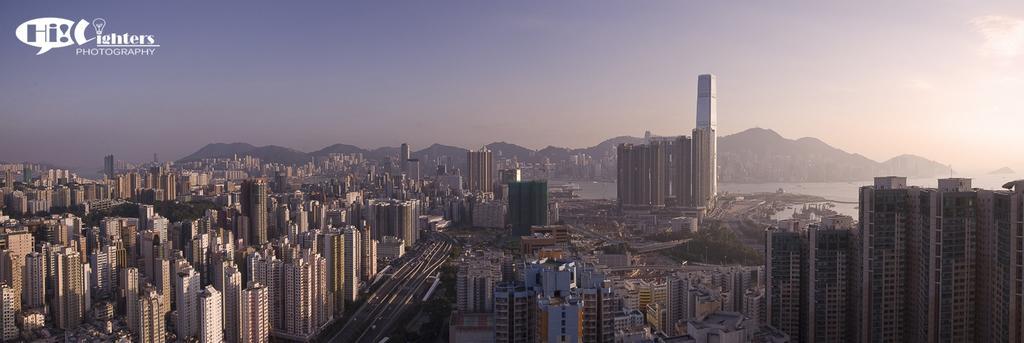How would you summarize this image in a sentence or two? In this picture we can see buildings, roads, trees, mountains, water, some objects and in the background we can see the sky and at the top left corner of this picture we can see some text. 